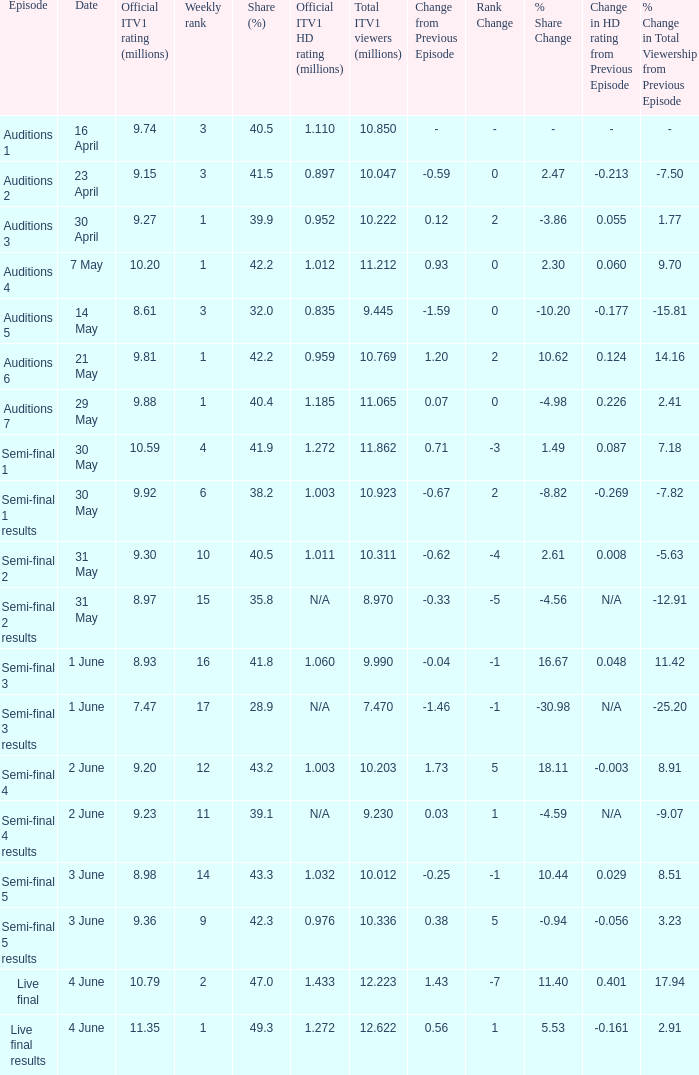How many million viewers did itv1 accumulate for the episode with a 28.9% audience share? 7.47. 